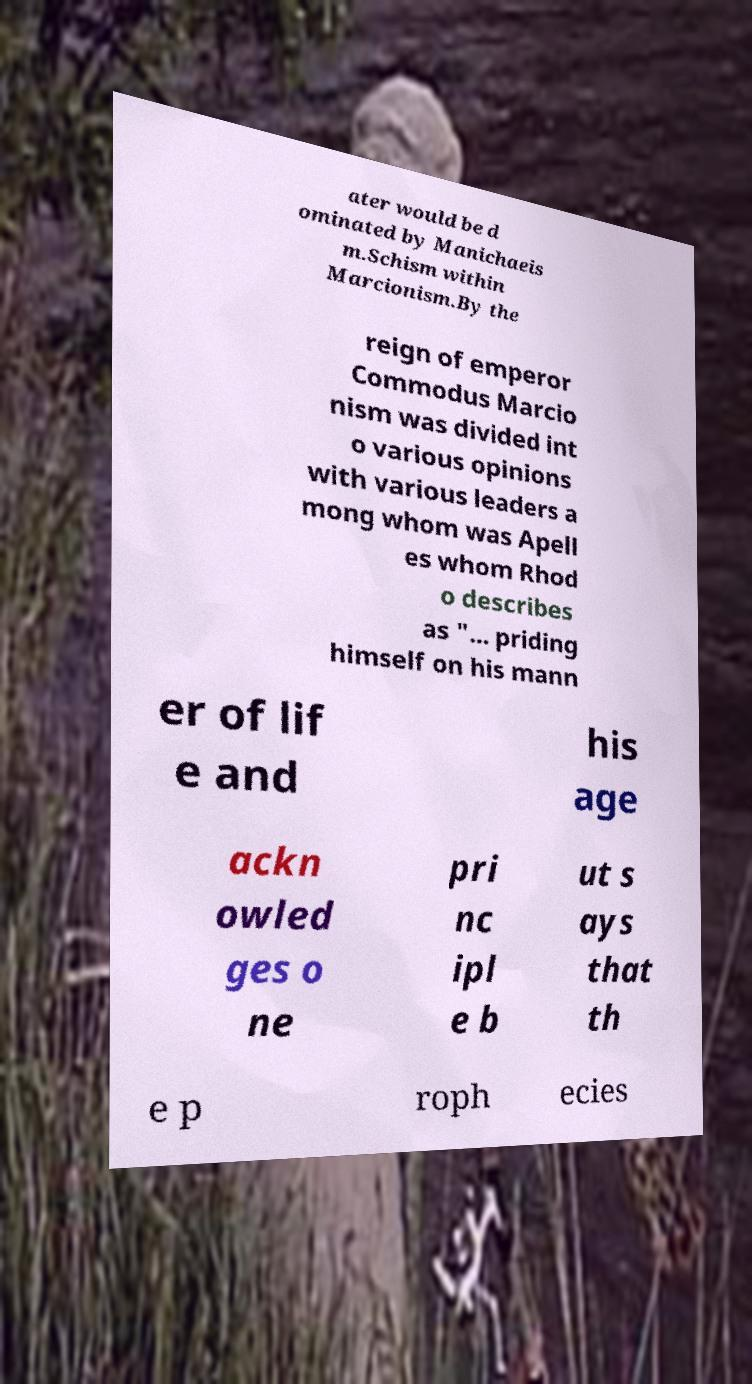Please identify and transcribe the text found in this image. ater would be d ominated by Manichaeis m.Schism within Marcionism.By the reign of emperor Commodus Marcio nism was divided int o various opinions with various leaders a mong whom was Apell es whom Rhod o describes as "... priding himself on his mann er of lif e and his age ackn owled ges o ne pri nc ipl e b ut s ays that th e p roph ecies 